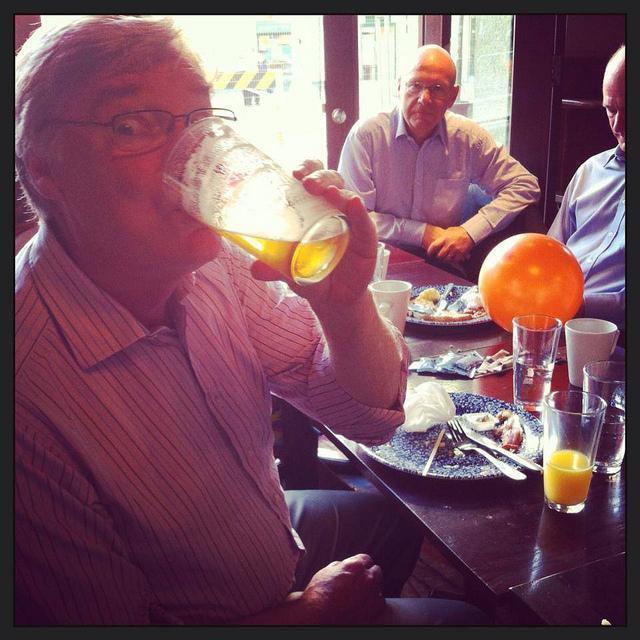What drug is this man ingesting?
Choose the correct response and explain in the format: 'Answer: answer
Rationale: rationale.'
Options: Marijuana, cocaine, mdma, alcohol. Answer: alcohol.
Rationale: He is drinking a beer. 